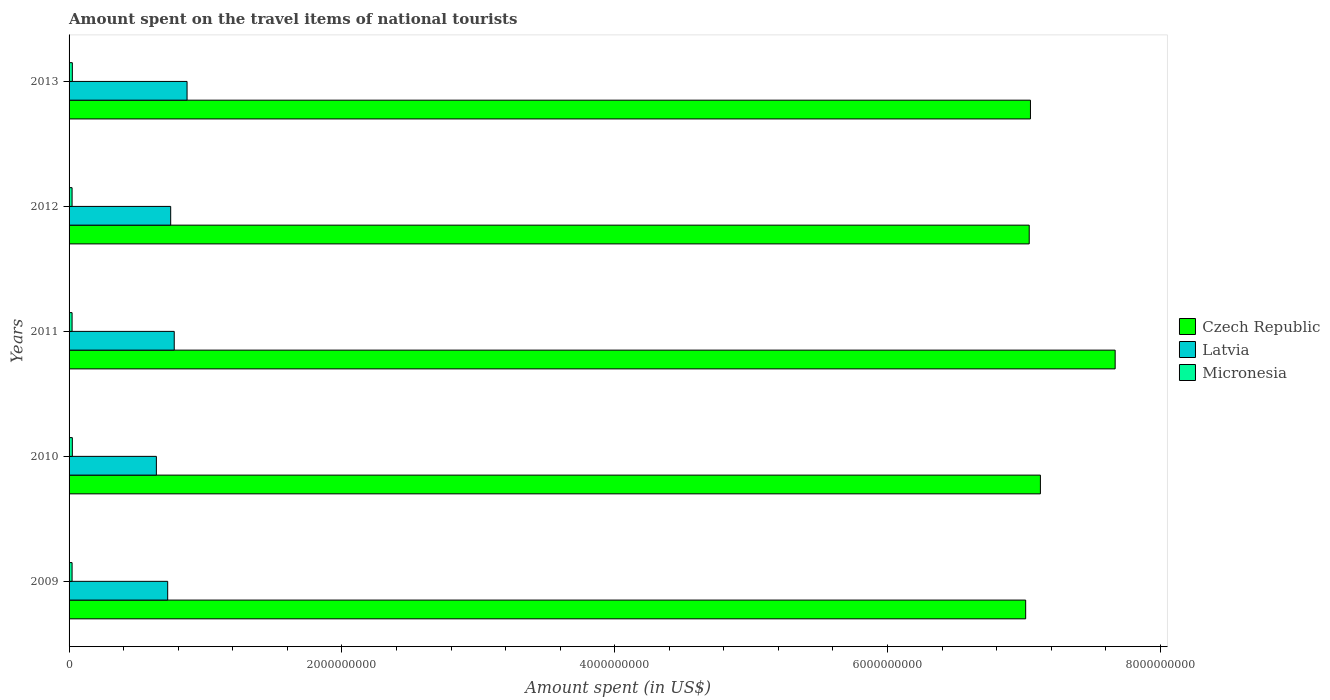How many different coloured bars are there?
Keep it short and to the point. 3. Are the number of bars on each tick of the Y-axis equal?
Your response must be concise. Yes. How many bars are there on the 4th tick from the top?
Give a very brief answer. 3. What is the label of the 5th group of bars from the top?
Your response must be concise. 2009. In how many cases, is the number of bars for a given year not equal to the number of legend labels?
Provide a succinct answer. 0. What is the amount spent on the travel items of national tourists in Latvia in 2012?
Give a very brief answer. 7.45e+08. Across all years, what is the maximum amount spent on the travel items of national tourists in Micronesia?
Your answer should be very brief. 2.40e+07. Across all years, what is the minimum amount spent on the travel items of national tourists in Micronesia?
Ensure brevity in your answer.  2.20e+07. In which year was the amount spent on the travel items of national tourists in Micronesia maximum?
Make the answer very short. 2010. In which year was the amount spent on the travel items of national tourists in Czech Republic minimum?
Keep it short and to the point. 2009. What is the total amount spent on the travel items of national tourists in Latvia in the graph?
Make the answer very short. 3.74e+09. What is the difference between the amount spent on the travel items of national tourists in Micronesia in 2011 and that in 2013?
Ensure brevity in your answer.  -2.00e+06. What is the difference between the amount spent on the travel items of national tourists in Czech Republic in 2010 and the amount spent on the travel items of national tourists in Latvia in 2013?
Give a very brief answer. 6.26e+09. What is the average amount spent on the travel items of national tourists in Czech Republic per year?
Your response must be concise. 7.18e+09. In the year 2013, what is the difference between the amount spent on the travel items of national tourists in Latvia and amount spent on the travel items of national tourists in Micronesia?
Give a very brief answer. 8.41e+08. What is the ratio of the amount spent on the travel items of national tourists in Micronesia in 2009 to that in 2012?
Ensure brevity in your answer.  1. Is the amount spent on the travel items of national tourists in Latvia in 2009 less than that in 2011?
Your answer should be compact. Yes. Is the difference between the amount spent on the travel items of national tourists in Latvia in 2009 and 2012 greater than the difference between the amount spent on the travel items of national tourists in Micronesia in 2009 and 2012?
Provide a short and direct response. No. What is the difference between the highest and the second highest amount spent on the travel items of national tourists in Latvia?
Keep it short and to the point. 9.40e+07. What does the 3rd bar from the top in 2009 represents?
Offer a very short reply. Czech Republic. What does the 2nd bar from the bottom in 2010 represents?
Offer a very short reply. Latvia. Is it the case that in every year, the sum of the amount spent on the travel items of national tourists in Latvia and amount spent on the travel items of national tourists in Czech Republic is greater than the amount spent on the travel items of national tourists in Micronesia?
Offer a very short reply. Yes. How many bars are there?
Offer a very short reply. 15. Are all the bars in the graph horizontal?
Offer a very short reply. Yes. Does the graph contain any zero values?
Your answer should be very brief. No. Does the graph contain grids?
Make the answer very short. No. How are the legend labels stacked?
Give a very brief answer. Vertical. What is the title of the graph?
Keep it short and to the point. Amount spent on the travel items of national tourists. What is the label or title of the X-axis?
Offer a very short reply. Amount spent (in US$). What is the Amount spent (in US$) in Czech Republic in 2009?
Offer a very short reply. 7.01e+09. What is the Amount spent (in US$) of Latvia in 2009?
Your response must be concise. 7.23e+08. What is the Amount spent (in US$) of Micronesia in 2009?
Provide a succinct answer. 2.20e+07. What is the Amount spent (in US$) in Czech Republic in 2010?
Offer a very short reply. 7.12e+09. What is the Amount spent (in US$) of Latvia in 2010?
Make the answer very short. 6.40e+08. What is the Amount spent (in US$) in Micronesia in 2010?
Offer a very short reply. 2.40e+07. What is the Amount spent (in US$) in Czech Republic in 2011?
Provide a short and direct response. 7.67e+09. What is the Amount spent (in US$) of Latvia in 2011?
Provide a succinct answer. 7.71e+08. What is the Amount spent (in US$) in Micronesia in 2011?
Make the answer very short. 2.20e+07. What is the Amount spent (in US$) in Czech Republic in 2012?
Your answer should be compact. 7.04e+09. What is the Amount spent (in US$) in Latvia in 2012?
Give a very brief answer. 7.45e+08. What is the Amount spent (in US$) of Micronesia in 2012?
Provide a short and direct response. 2.20e+07. What is the Amount spent (in US$) of Czech Republic in 2013?
Your answer should be compact. 7.05e+09. What is the Amount spent (in US$) of Latvia in 2013?
Make the answer very short. 8.65e+08. What is the Amount spent (in US$) of Micronesia in 2013?
Your answer should be very brief. 2.40e+07. Across all years, what is the maximum Amount spent (in US$) of Czech Republic?
Provide a succinct answer. 7.67e+09. Across all years, what is the maximum Amount spent (in US$) in Latvia?
Provide a short and direct response. 8.65e+08. Across all years, what is the maximum Amount spent (in US$) of Micronesia?
Offer a very short reply. 2.40e+07. Across all years, what is the minimum Amount spent (in US$) in Czech Republic?
Give a very brief answer. 7.01e+09. Across all years, what is the minimum Amount spent (in US$) of Latvia?
Provide a succinct answer. 6.40e+08. Across all years, what is the minimum Amount spent (in US$) of Micronesia?
Provide a succinct answer. 2.20e+07. What is the total Amount spent (in US$) of Czech Republic in the graph?
Provide a succinct answer. 3.59e+1. What is the total Amount spent (in US$) in Latvia in the graph?
Offer a very short reply. 3.74e+09. What is the total Amount spent (in US$) in Micronesia in the graph?
Make the answer very short. 1.14e+08. What is the difference between the Amount spent (in US$) in Czech Republic in 2009 and that in 2010?
Give a very brief answer. -1.08e+08. What is the difference between the Amount spent (in US$) of Latvia in 2009 and that in 2010?
Make the answer very short. 8.30e+07. What is the difference between the Amount spent (in US$) in Micronesia in 2009 and that in 2010?
Provide a succinct answer. -2.00e+06. What is the difference between the Amount spent (in US$) of Czech Republic in 2009 and that in 2011?
Offer a very short reply. -6.56e+08. What is the difference between the Amount spent (in US$) in Latvia in 2009 and that in 2011?
Your response must be concise. -4.80e+07. What is the difference between the Amount spent (in US$) of Czech Republic in 2009 and that in 2012?
Provide a short and direct response. -2.60e+07. What is the difference between the Amount spent (in US$) of Latvia in 2009 and that in 2012?
Provide a succinct answer. -2.20e+07. What is the difference between the Amount spent (in US$) in Czech Republic in 2009 and that in 2013?
Offer a terse response. -3.50e+07. What is the difference between the Amount spent (in US$) in Latvia in 2009 and that in 2013?
Your response must be concise. -1.42e+08. What is the difference between the Amount spent (in US$) in Czech Republic in 2010 and that in 2011?
Offer a very short reply. -5.48e+08. What is the difference between the Amount spent (in US$) of Latvia in 2010 and that in 2011?
Provide a short and direct response. -1.31e+08. What is the difference between the Amount spent (in US$) in Micronesia in 2010 and that in 2011?
Your answer should be compact. 2.00e+06. What is the difference between the Amount spent (in US$) in Czech Republic in 2010 and that in 2012?
Make the answer very short. 8.20e+07. What is the difference between the Amount spent (in US$) in Latvia in 2010 and that in 2012?
Keep it short and to the point. -1.05e+08. What is the difference between the Amount spent (in US$) of Czech Republic in 2010 and that in 2013?
Give a very brief answer. 7.30e+07. What is the difference between the Amount spent (in US$) of Latvia in 2010 and that in 2013?
Your answer should be compact. -2.25e+08. What is the difference between the Amount spent (in US$) of Micronesia in 2010 and that in 2013?
Offer a terse response. 0. What is the difference between the Amount spent (in US$) in Czech Republic in 2011 and that in 2012?
Your answer should be compact. 6.30e+08. What is the difference between the Amount spent (in US$) in Latvia in 2011 and that in 2012?
Your response must be concise. 2.60e+07. What is the difference between the Amount spent (in US$) of Micronesia in 2011 and that in 2012?
Your answer should be compact. 0. What is the difference between the Amount spent (in US$) in Czech Republic in 2011 and that in 2013?
Offer a very short reply. 6.21e+08. What is the difference between the Amount spent (in US$) in Latvia in 2011 and that in 2013?
Make the answer very short. -9.40e+07. What is the difference between the Amount spent (in US$) in Czech Republic in 2012 and that in 2013?
Keep it short and to the point. -9.00e+06. What is the difference between the Amount spent (in US$) of Latvia in 2012 and that in 2013?
Keep it short and to the point. -1.20e+08. What is the difference between the Amount spent (in US$) of Czech Republic in 2009 and the Amount spent (in US$) of Latvia in 2010?
Make the answer very short. 6.37e+09. What is the difference between the Amount spent (in US$) of Czech Republic in 2009 and the Amount spent (in US$) of Micronesia in 2010?
Provide a short and direct response. 6.99e+09. What is the difference between the Amount spent (in US$) of Latvia in 2009 and the Amount spent (in US$) of Micronesia in 2010?
Offer a very short reply. 6.99e+08. What is the difference between the Amount spent (in US$) in Czech Republic in 2009 and the Amount spent (in US$) in Latvia in 2011?
Your answer should be very brief. 6.24e+09. What is the difference between the Amount spent (in US$) of Czech Republic in 2009 and the Amount spent (in US$) of Micronesia in 2011?
Offer a very short reply. 6.99e+09. What is the difference between the Amount spent (in US$) in Latvia in 2009 and the Amount spent (in US$) in Micronesia in 2011?
Provide a succinct answer. 7.01e+08. What is the difference between the Amount spent (in US$) of Czech Republic in 2009 and the Amount spent (in US$) of Latvia in 2012?
Make the answer very short. 6.27e+09. What is the difference between the Amount spent (in US$) in Czech Republic in 2009 and the Amount spent (in US$) in Micronesia in 2012?
Your answer should be compact. 6.99e+09. What is the difference between the Amount spent (in US$) of Latvia in 2009 and the Amount spent (in US$) of Micronesia in 2012?
Make the answer very short. 7.01e+08. What is the difference between the Amount spent (in US$) in Czech Republic in 2009 and the Amount spent (in US$) in Latvia in 2013?
Keep it short and to the point. 6.15e+09. What is the difference between the Amount spent (in US$) of Czech Republic in 2009 and the Amount spent (in US$) of Micronesia in 2013?
Offer a terse response. 6.99e+09. What is the difference between the Amount spent (in US$) in Latvia in 2009 and the Amount spent (in US$) in Micronesia in 2013?
Your answer should be compact. 6.99e+08. What is the difference between the Amount spent (in US$) in Czech Republic in 2010 and the Amount spent (in US$) in Latvia in 2011?
Provide a short and direct response. 6.35e+09. What is the difference between the Amount spent (in US$) of Czech Republic in 2010 and the Amount spent (in US$) of Micronesia in 2011?
Your answer should be compact. 7.10e+09. What is the difference between the Amount spent (in US$) in Latvia in 2010 and the Amount spent (in US$) in Micronesia in 2011?
Your answer should be very brief. 6.18e+08. What is the difference between the Amount spent (in US$) of Czech Republic in 2010 and the Amount spent (in US$) of Latvia in 2012?
Ensure brevity in your answer.  6.38e+09. What is the difference between the Amount spent (in US$) of Czech Republic in 2010 and the Amount spent (in US$) of Micronesia in 2012?
Give a very brief answer. 7.10e+09. What is the difference between the Amount spent (in US$) of Latvia in 2010 and the Amount spent (in US$) of Micronesia in 2012?
Ensure brevity in your answer.  6.18e+08. What is the difference between the Amount spent (in US$) of Czech Republic in 2010 and the Amount spent (in US$) of Latvia in 2013?
Offer a terse response. 6.26e+09. What is the difference between the Amount spent (in US$) in Czech Republic in 2010 and the Amount spent (in US$) in Micronesia in 2013?
Give a very brief answer. 7.10e+09. What is the difference between the Amount spent (in US$) of Latvia in 2010 and the Amount spent (in US$) of Micronesia in 2013?
Make the answer very short. 6.16e+08. What is the difference between the Amount spent (in US$) in Czech Republic in 2011 and the Amount spent (in US$) in Latvia in 2012?
Offer a very short reply. 6.92e+09. What is the difference between the Amount spent (in US$) of Czech Republic in 2011 and the Amount spent (in US$) of Micronesia in 2012?
Your answer should be very brief. 7.65e+09. What is the difference between the Amount spent (in US$) in Latvia in 2011 and the Amount spent (in US$) in Micronesia in 2012?
Your answer should be compact. 7.49e+08. What is the difference between the Amount spent (in US$) of Czech Republic in 2011 and the Amount spent (in US$) of Latvia in 2013?
Your answer should be compact. 6.80e+09. What is the difference between the Amount spent (in US$) in Czech Republic in 2011 and the Amount spent (in US$) in Micronesia in 2013?
Make the answer very short. 7.64e+09. What is the difference between the Amount spent (in US$) of Latvia in 2011 and the Amount spent (in US$) of Micronesia in 2013?
Your answer should be compact. 7.47e+08. What is the difference between the Amount spent (in US$) of Czech Republic in 2012 and the Amount spent (in US$) of Latvia in 2013?
Offer a very short reply. 6.17e+09. What is the difference between the Amount spent (in US$) of Czech Republic in 2012 and the Amount spent (in US$) of Micronesia in 2013?
Provide a succinct answer. 7.02e+09. What is the difference between the Amount spent (in US$) in Latvia in 2012 and the Amount spent (in US$) in Micronesia in 2013?
Your answer should be very brief. 7.21e+08. What is the average Amount spent (in US$) of Czech Republic per year?
Your answer should be very brief. 7.18e+09. What is the average Amount spent (in US$) in Latvia per year?
Your response must be concise. 7.49e+08. What is the average Amount spent (in US$) in Micronesia per year?
Give a very brief answer. 2.28e+07. In the year 2009, what is the difference between the Amount spent (in US$) in Czech Republic and Amount spent (in US$) in Latvia?
Give a very brief answer. 6.29e+09. In the year 2009, what is the difference between the Amount spent (in US$) of Czech Republic and Amount spent (in US$) of Micronesia?
Provide a succinct answer. 6.99e+09. In the year 2009, what is the difference between the Amount spent (in US$) in Latvia and Amount spent (in US$) in Micronesia?
Keep it short and to the point. 7.01e+08. In the year 2010, what is the difference between the Amount spent (in US$) of Czech Republic and Amount spent (in US$) of Latvia?
Offer a terse response. 6.48e+09. In the year 2010, what is the difference between the Amount spent (in US$) of Czech Republic and Amount spent (in US$) of Micronesia?
Your response must be concise. 7.10e+09. In the year 2010, what is the difference between the Amount spent (in US$) in Latvia and Amount spent (in US$) in Micronesia?
Offer a terse response. 6.16e+08. In the year 2011, what is the difference between the Amount spent (in US$) of Czech Republic and Amount spent (in US$) of Latvia?
Your response must be concise. 6.90e+09. In the year 2011, what is the difference between the Amount spent (in US$) of Czech Republic and Amount spent (in US$) of Micronesia?
Provide a succinct answer. 7.65e+09. In the year 2011, what is the difference between the Amount spent (in US$) in Latvia and Amount spent (in US$) in Micronesia?
Provide a short and direct response. 7.49e+08. In the year 2012, what is the difference between the Amount spent (in US$) in Czech Republic and Amount spent (in US$) in Latvia?
Provide a succinct answer. 6.29e+09. In the year 2012, what is the difference between the Amount spent (in US$) of Czech Republic and Amount spent (in US$) of Micronesia?
Provide a short and direct response. 7.02e+09. In the year 2012, what is the difference between the Amount spent (in US$) of Latvia and Amount spent (in US$) of Micronesia?
Provide a short and direct response. 7.23e+08. In the year 2013, what is the difference between the Amount spent (in US$) of Czech Republic and Amount spent (in US$) of Latvia?
Provide a short and direct response. 6.18e+09. In the year 2013, what is the difference between the Amount spent (in US$) of Czech Republic and Amount spent (in US$) of Micronesia?
Give a very brief answer. 7.02e+09. In the year 2013, what is the difference between the Amount spent (in US$) of Latvia and Amount spent (in US$) of Micronesia?
Offer a very short reply. 8.41e+08. What is the ratio of the Amount spent (in US$) of Latvia in 2009 to that in 2010?
Your answer should be compact. 1.13. What is the ratio of the Amount spent (in US$) in Czech Republic in 2009 to that in 2011?
Keep it short and to the point. 0.91. What is the ratio of the Amount spent (in US$) of Latvia in 2009 to that in 2011?
Offer a very short reply. 0.94. What is the ratio of the Amount spent (in US$) in Latvia in 2009 to that in 2012?
Ensure brevity in your answer.  0.97. What is the ratio of the Amount spent (in US$) in Micronesia in 2009 to that in 2012?
Keep it short and to the point. 1. What is the ratio of the Amount spent (in US$) in Czech Republic in 2009 to that in 2013?
Offer a terse response. 0.99. What is the ratio of the Amount spent (in US$) of Latvia in 2009 to that in 2013?
Offer a very short reply. 0.84. What is the ratio of the Amount spent (in US$) in Czech Republic in 2010 to that in 2011?
Your response must be concise. 0.93. What is the ratio of the Amount spent (in US$) of Latvia in 2010 to that in 2011?
Provide a succinct answer. 0.83. What is the ratio of the Amount spent (in US$) in Czech Republic in 2010 to that in 2012?
Ensure brevity in your answer.  1.01. What is the ratio of the Amount spent (in US$) of Latvia in 2010 to that in 2012?
Your answer should be very brief. 0.86. What is the ratio of the Amount spent (in US$) of Micronesia in 2010 to that in 2012?
Your response must be concise. 1.09. What is the ratio of the Amount spent (in US$) in Czech Republic in 2010 to that in 2013?
Keep it short and to the point. 1.01. What is the ratio of the Amount spent (in US$) of Latvia in 2010 to that in 2013?
Your answer should be compact. 0.74. What is the ratio of the Amount spent (in US$) of Micronesia in 2010 to that in 2013?
Give a very brief answer. 1. What is the ratio of the Amount spent (in US$) of Czech Republic in 2011 to that in 2012?
Offer a very short reply. 1.09. What is the ratio of the Amount spent (in US$) in Latvia in 2011 to that in 2012?
Make the answer very short. 1.03. What is the ratio of the Amount spent (in US$) in Micronesia in 2011 to that in 2012?
Offer a terse response. 1. What is the ratio of the Amount spent (in US$) in Czech Republic in 2011 to that in 2013?
Your answer should be very brief. 1.09. What is the ratio of the Amount spent (in US$) in Latvia in 2011 to that in 2013?
Your answer should be very brief. 0.89. What is the ratio of the Amount spent (in US$) in Micronesia in 2011 to that in 2013?
Offer a terse response. 0.92. What is the ratio of the Amount spent (in US$) of Czech Republic in 2012 to that in 2013?
Provide a succinct answer. 1. What is the ratio of the Amount spent (in US$) of Latvia in 2012 to that in 2013?
Ensure brevity in your answer.  0.86. What is the ratio of the Amount spent (in US$) in Micronesia in 2012 to that in 2013?
Offer a terse response. 0.92. What is the difference between the highest and the second highest Amount spent (in US$) in Czech Republic?
Keep it short and to the point. 5.48e+08. What is the difference between the highest and the second highest Amount spent (in US$) in Latvia?
Ensure brevity in your answer.  9.40e+07. What is the difference between the highest and the lowest Amount spent (in US$) in Czech Republic?
Ensure brevity in your answer.  6.56e+08. What is the difference between the highest and the lowest Amount spent (in US$) of Latvia?
Your answer should be very brief. 2.25e+08. What is the difference between the highest and the lowest Amount spent (in US$) in Micronesia?
Keep it short and to the point. 2.00e+06. 